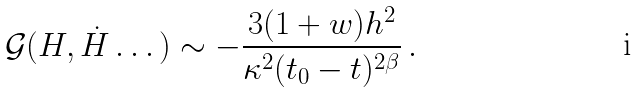Convert formula to latex. <formula><loc_0><loc_0><loc_500><loc_500>\mathcal { G } ( H , \dot { H } \dots ) \sim - \frac { 3 ( 1 + w ) h ^ { 2 } } { \kappa ^ { 2 } ( t _ { 0 } - t ) ^ { 2 \beta } } \, .</formula> 